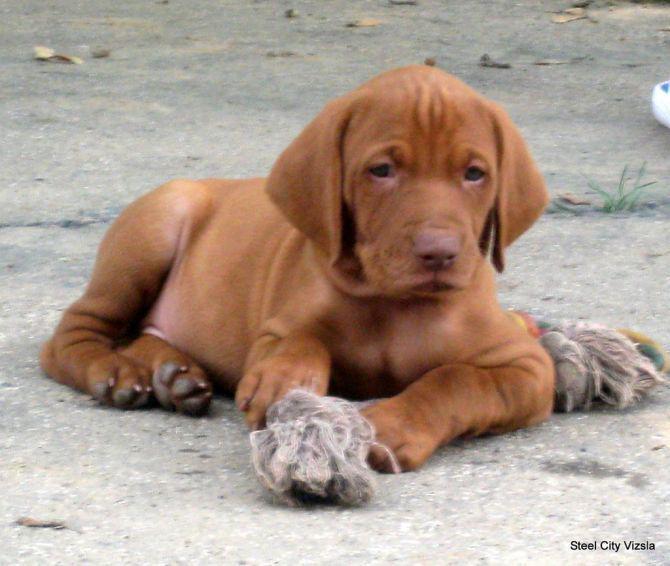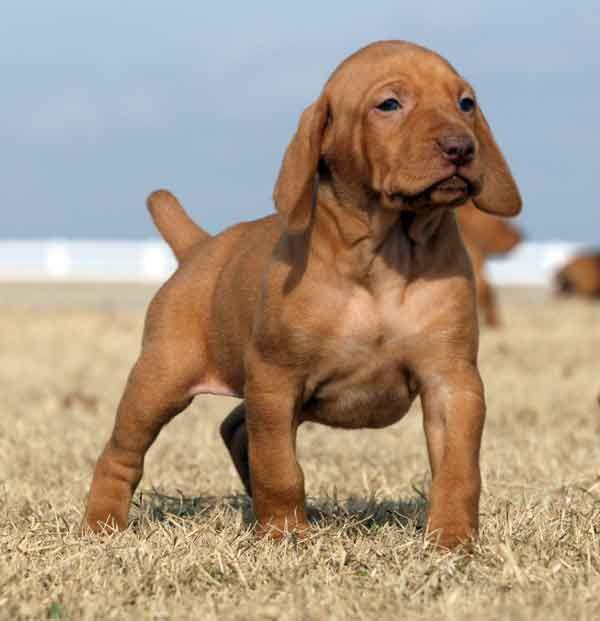The first image is the image on the left, the second image is the image on the right. Examine the images to the left and right. Is the description "There are three dogs." accurate? Answer yes or no. No. The first image is the image on the left, the second image is the image on the right. Considering the images on both sides, is "Each image contains just one dog, and the left image features a young dog reclining with its head upright and front paws forward." valid? Answer yes or no. Yes. 